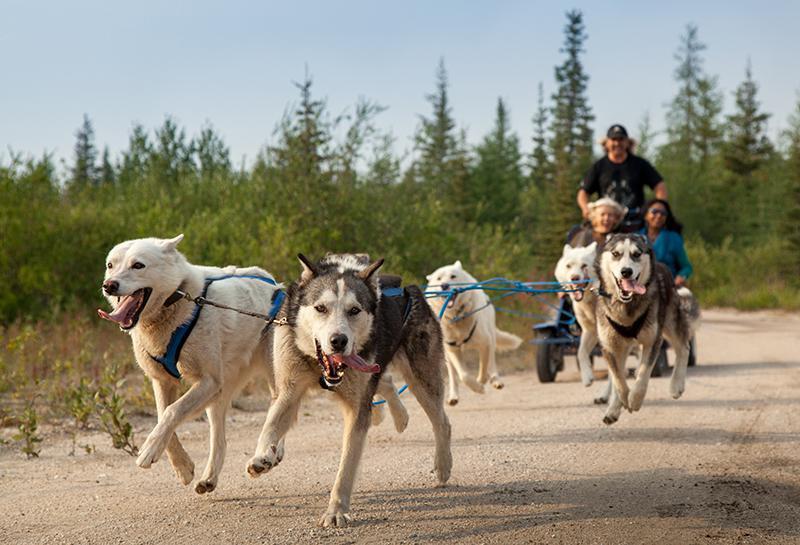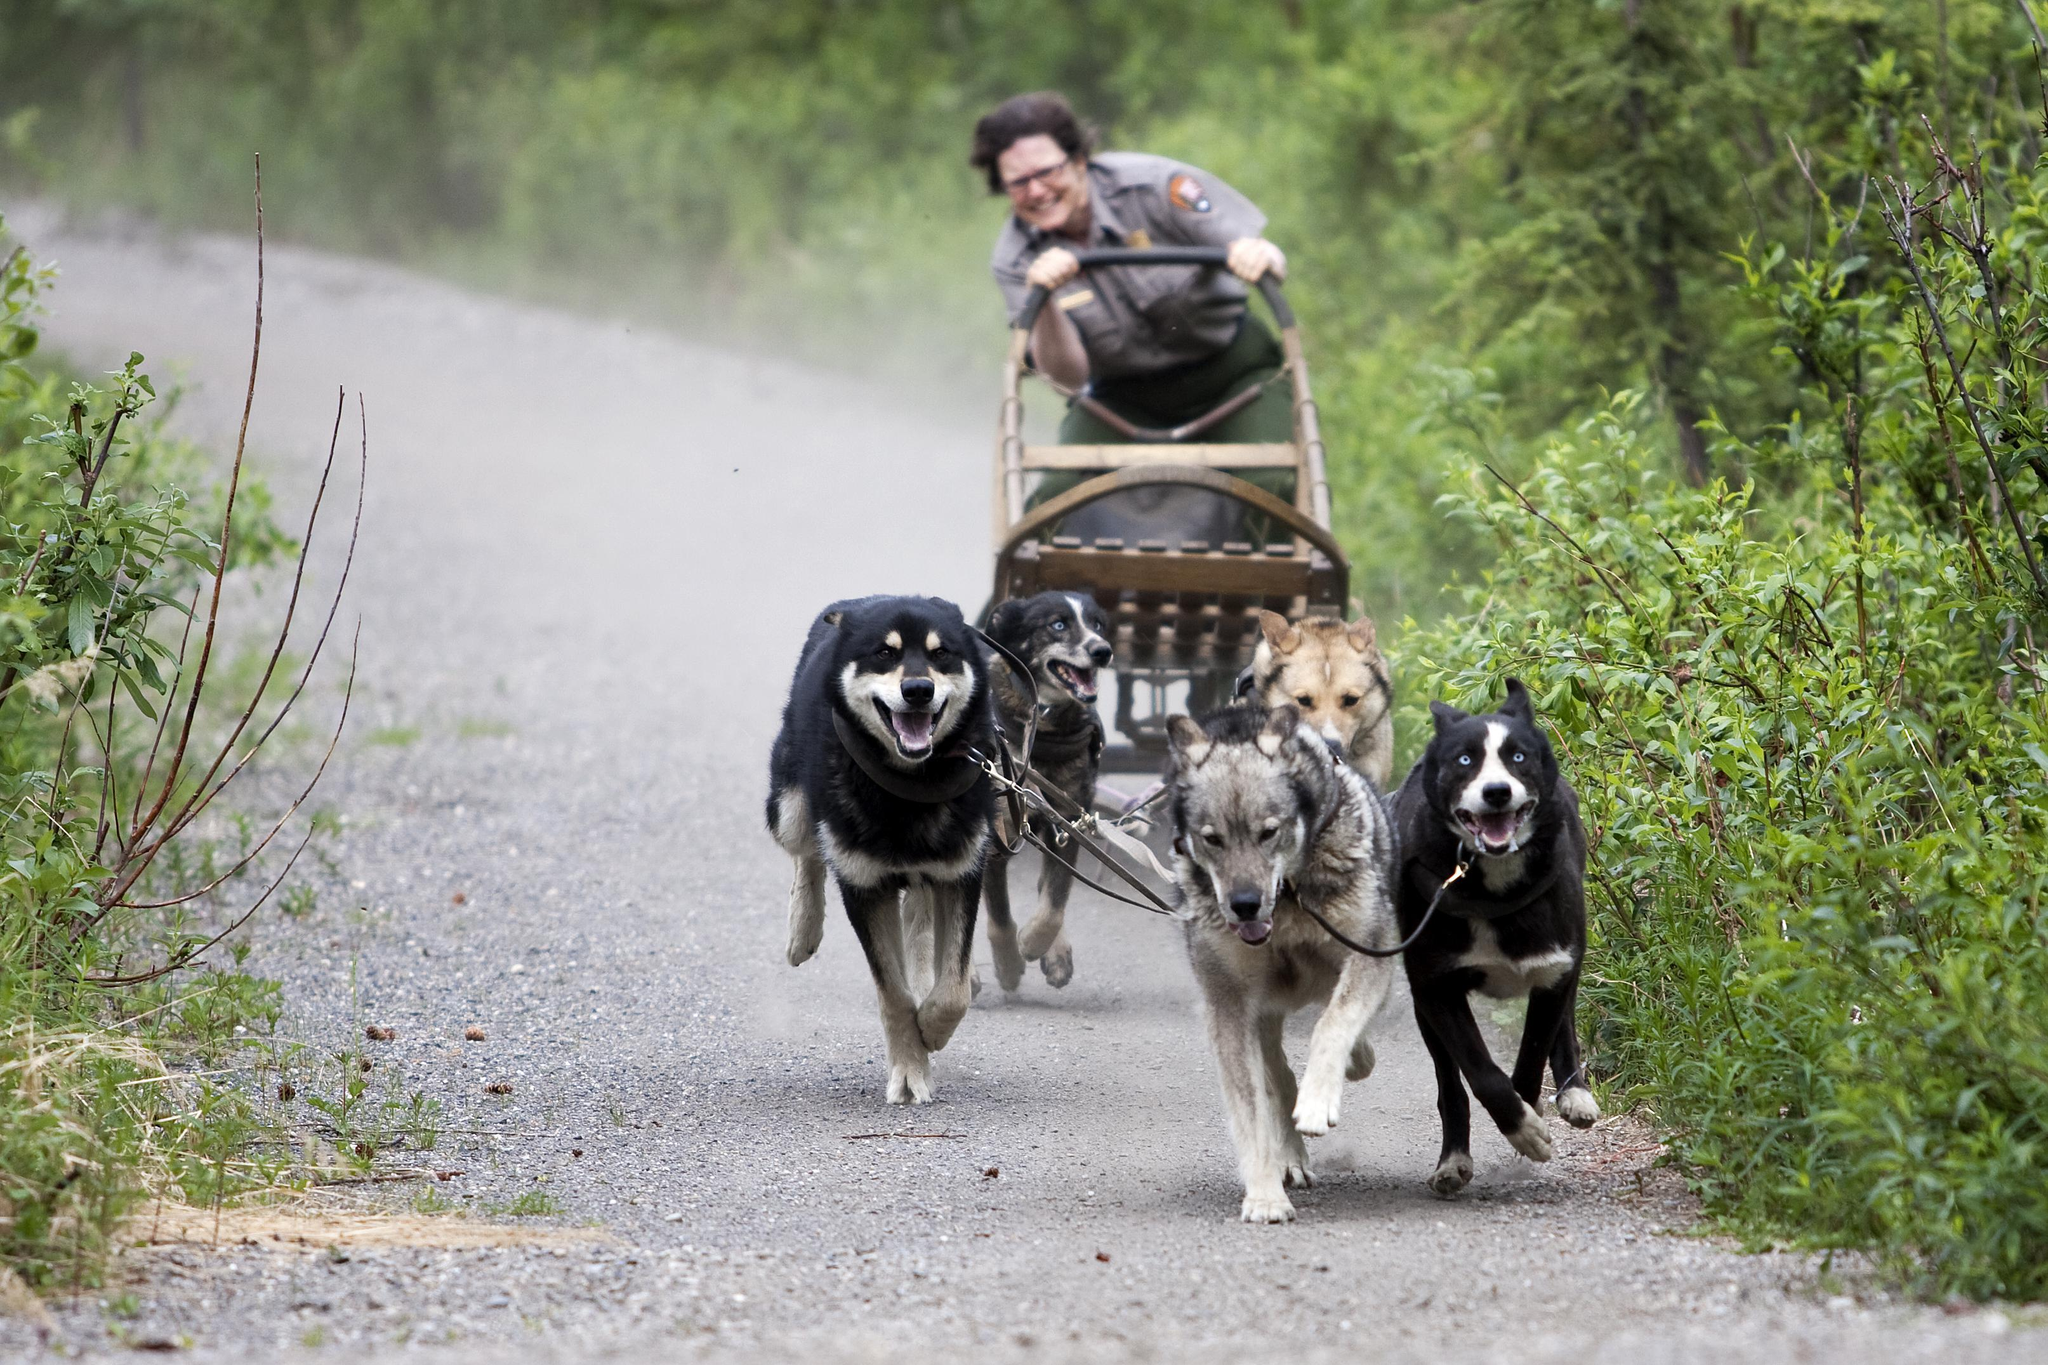The first image is the image on the left, the second image is the image on the right. Assess this claim about the two images: "Three people are riding a sled in one of the images.". Correct or not? Answer yes or no. Yes. 